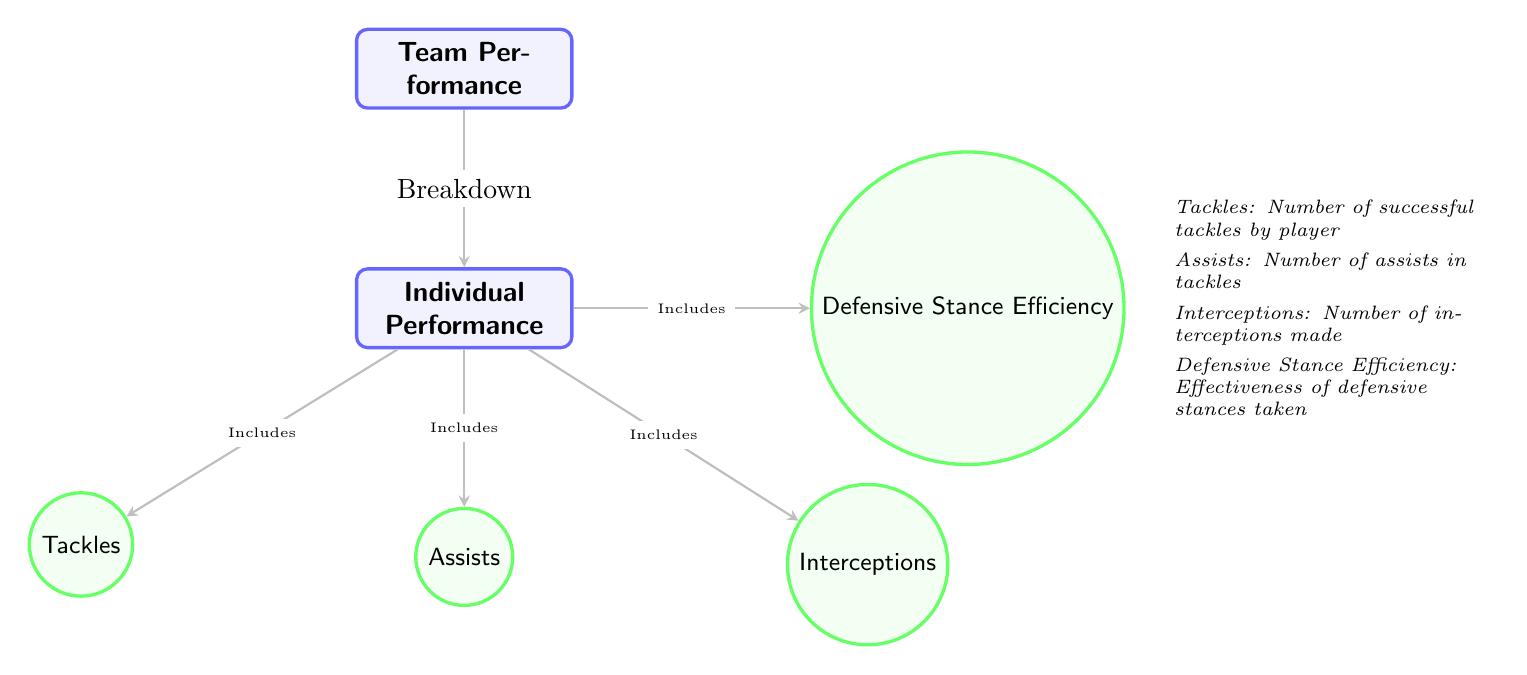What are the main categories of performance represented in the diagram? The diagram shows two main categories: Team Performance and Individual Performance. These are the highest-level nodes in the structure.
Answer: Team Performance, Individual Performance How many individual performance metrics are included in the diagram? The diagram lists four individual performance metrics: Tackles, Assists, Interceptions, and Defensive Stance Efficiency. Counting these metrics gives the total.
Answer: 4 What includes Tackles in the diagram? The diagram indicates that Tackles are part of Individual Performance. The arrow labeling "Includes" connects Individual Performance to Tackles, confirming this relationship.
Answer: Individual Performance Which performance metric emphasizes effectiveness in defensive plays? Defensive Stance Efficiency is identified in the diagram as the metric that assesses effectiveness in defensive stances taken. The label is directly included in the structure.
Answer: Defensive Stance Efficiency What is the relationship between Team Performance and Individual Performance? Team Performance is shown to break down into Individual Performance in the diagram. An arrow labeled "Breakdown" connects these two categories, indicating a hierarchical relationship.
Answer: Breakdown Explain how Assists relate to the other individual performance metrics. Assists is listed as one of four individual performance metrics. It shares the same level of hierarchy with Tackles, Interceptions, and Defensive Stance Efficiency, indicating they are all components of Individual Performance.
Answer: They are all components of Individual Performance How many nodes are there in total in the diagram? The diagram has a total of six nodes. This includes one node for Team Performance, one for Individual Performance, and four for the individual performance metrics. Counting all these nodes gives the total.
Answer: 6 What is the significance of the arrows in the diagram? The arrows indicate relationships between nodes; specifically, they show breakdowns and inclusions between Team Performance, Individual Performance, and the metrics associated with individual performance. This indicates how categories are connected.
Answer: They indicate relationships between nodes 